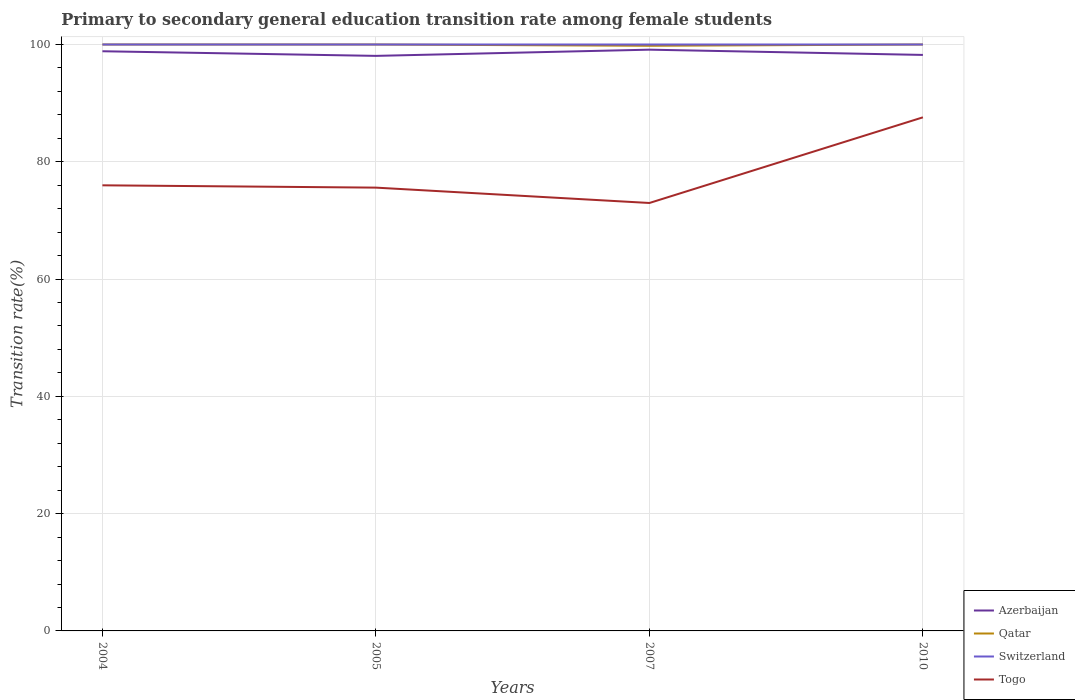How many different coloured lines are there?
Provide a short and direct response. 4. Across all years, what is the maximum transition rate in Azerbaijan?
Make the answer very short. 98.06. What is the total transition rate in Qatar in the graph?
Keep it short and to the point. -0.22. What is the difference between the highest and the second highest transition rate in Togo?
Keep it short and to the point. 14.61. How many years are there in the graph?
Keep it short and to the point. 4. What is the difference between two consecutive major ticks on the Y-axis?
Ensure brevity in your answer.  20. Are the values on the major ticks of Y-axis written in scientific E-notation?
Your response must be concise. No. Does the graph contain any zero values?
Your answer should be compact. No. How many legend labels are there?
Your answer should be compact. 4. What is the title of the graph?
Provide a short and direct response. Primary to secondary general education transition rate among female students. What is the label or title of the X-axis?
Your response must be concise. Years. What is the label or title of the Y-axis?
Your answer should be compact. Transition rate(%). What is the Transition rate(%) in Azerbaijan in 2004?
Offer a very short reply. 98.85. What is the Transition rate(%) in Qatar in 2004?
Offer a very short reply. 100. What is the Transition rate(%) in Togo in 2004?
Provide a short and direct response. 75.99. What is the Transition rate(%) of Azerbaijan in 2005?
Your response must be concise. 98.06. What is the Transition rate(%) in Togo in 2005?
Your response must be concise. 75.59. What is the Transition rate(%) in Azerbaijan in 2007?
Keep it short and to the point. 99.12. What is the Transition rate(%) in Qatar in 2007?
Your response must be concise. 99.78. What is the Transition rate(%) of Switzerland in 2007?
Your answer should be very brief. 100. What is the Transition rate(%) in Togo in 2007?
Ensure brevity in your answer.  72.97. What is the Transition rate(%) in Azerbaijan in 2010?
Provide a short and direct response. 98.22. What is the Transition rate(%) of Qatar in 2010?
Offer a very short reply. 100. What is the Transition rate(%) in Togo in 2010?
Provide a succinct answer. 87.58. Across all years, what is the maximum Transition rate(%) in Azerbaijan?
Your response must be concise. 99.12. Across all years, what is the maximum Transition rate(%) of Qatar?
Offer a terse response. 100. Across all years, what is the maximum Transition rate(%) in Togo?
Make the answer very short. 87.58. Across all years, what is the minimum Transition rate(%) in Azerbaijan?
Provide a succinct answer. 98.06. Across all years, what is the minimum Transition rate(%) of Qatar?
Your response must be concise. 99.78. Across all years, what is the minimum Transition rate(%) in Togo?
Your answer should be compact. 72.97. What is the total Transition rate(%) in Azerbaijan in the graph?
Your response must be concise. 394.25. What is the total Transition rate(%) of Qatar in the graph?
Give a very brief answer. 399.78. What is the total Transition rate(%) of Togo in the graph?
Make the answer very short. 312.14. What is the difference between the Transition rate(%) of Azerbaijan in 2004 and that in 2005?
Ensure brevity in your answer.  0.79. What is the difference between the Transition rate(%) of Togo in 2004 and that in 2005?
Your answer should be very brief. 0.39. What is the difference between the Transition rate(%) of Azerbaijan in 2004 and that in 2007?
Offer a terse response. -0.27. What is the difference between the Transition rate(%) of Qatar in 2004 and that in 2007?
Your response must be concise. 0.22. What is the difference between the Transition rate(%) in Switzerland in 2004 and that in 2007?
Your answer should be compact. 0. What is the difference between the Transition rate(%) in Togo in 2004 and that in 2007?
Give a very brief answer. 3.01. What is the difference between the Transition rate(%) in Azerbaijan in 2004 and that in 2010?
Keep it short and to the point. 0.63. What is the difference between the Transition rate(%) of Switzerland in 2004 and that in 2010?
Make the answer very short. 0. What is the difference between the Transition rate(%) of Togo in 2004 and that in 2010?
Your answer should be compact. -11.59. What is the difference between the Transition rate(%) of Azerbaijan in 2005 and that in 2007?
Provide a short and direct response. -1.06. What is the difference between the Transition rate(%) in Qatar in 2005 and that in 2007?
Provide a short and direct response. 0.22. What is the difference between the Transition rate(%) of Switzerland in 2005 and that in 2007?
Provide a succinct answer. 0. What is the difference between the Transition rate(%) of Togo in 2005 and that in 2007?
Offer a terse response. 2.62. What is the difference between the Transition rate(%) in Azerbaijan in 2005 and that in 2010?
Your answer should be very brief. -0.16. What is the difference between the Transition rate(%) in Qatar in 2005 and that in 2010?
Offer a very short reply. 0. What is the difference between the Transition rate(%) in Switzerland in 2005 and that in 2010?
Provide a succinct answer. 0. What is the difference between the Transition rate(%) of Togo in 2005 and that in 2010?
Your response must be concise. -11.99. What is the difference between the Transition rate(%) of Azerbaijan in 2007 and that in 2010?
Give a very brief answer. 0.9. What is the difference between the Transition rate(%) of Qatar in 2007 and that in 2010?
Your response must be concise. -0.22. What is the difference between the Transition rate(%) of Switzerland in 2007 and that in 2010?
Ensure brevity in your answer.  0. What is the difference between the Transition rate(%) of Togo in 2007 and that in 2010?
Provide a succinct answer. -14.61. What is the difference between the Transition rate(%) in Azerbaijan in 2004 and the Transition rate(%) in Qatar in 2005?
Offer a very short reply. -1.15. What is the difference between the Transition rate(%) of Azerbaijan in 2004 and the Transition rate(%) of Switzerland in 2005?
Keep it short and to the point. -1.15. What is the difference between the Transition rate(%) in Azerbaijan in 2004 and the Transition rate(%) in Togo in 2005?
Your answer should be very brief. 23.25. What is the difference between the Transition rate(%) of Qatar in 2004 and the Transition rate(%) of Switzerland in 2005?
Your response must be concise. 0. What is the difference between the Transition rate(%) of Qatar in 2004 and the Transition rate(%) of Togo in 2005?
Your answer should be compact. 24.41. What is the difference between the Transition rate(%) in Switzerland in 2004 and the Transition rate(%) in Togo in 2005?
Give a very brief answer. 24.41. What is the difference between the Transition rate(%) of Azerbaijan in 2004 and the Transition rate(%) of Qatar in 2007?
Your answer should be very brief. -0.93. What is the difference between the Transition rate(%) in Azerbaijan in 2004 and the Transition rate(%) in Switzerland in 2007?
Give a very brief answer. -1.15. What is the difference between the Transition rate(%) of Azerbaijan in 2004 and the Transition rate(%) of Togo in 2007?
Provide a short and direct response. 25.87. What is the difference between the Transition rate(%) in Qatar in 2004 and the Transition rate(%) in Switzerland in 2007?
Give a very brief answer. 0. What is the difference between the Transition rate(%) in Qatar in 2004 and the Transition rate(%) in Togo in 2007?
Your answer should be very brief. 27.03. What is the difference between the Transition rate(%) in Switzerland in 2004 and the Transition rate(%) in Togo in 2007?
Offer a terse response. 27.03. What is the difference between the Transition rate(%) of Azerbaijan in 2004 and the Transition rate(%) of Qatar in 2010?
Offer a very short reply. -1.15. What is the difference between the Transition rate(%) in Azerbaijan in 2004 and the Transition rate(%) in Switzerland in 2010?
Provide a succinct answer. -1.15. What is the difference between the Transition rate(%) in Azerbaijan in 2004 and the Transition rate(%) in Togo in 2010?
Offer a terse response. 11.27. What is the difference between the Transition rate(%) in Qatar in 2004 and the Transition rate(%) in Togo in 2010?
Ensure brevity in your answer.  12.42. What is the difference between the Transition rate(%) of Switzerland in 2004 and the Transition rate(%) of Togo in 2010?
Make the answer very short. 12.42. What is the difference between the Transition rate(%) of Azerbaijan in 2005 and the Transition rate(%) of Qatar in 2007?
Your answer should be compact. -1.72. What is the difference between the Transition rate(%) of Azerbaijan in 2005 and the Transition rate(%) of Switzerland in 2007?
Provide a succinct answer. -1.94. What is the difference between the Transition rate(%) in Azerbaijan in 2005 and the Transition rate(%) in Togo in 2007?
Give a very brief answer. 25.09. What is the difference between the Transition rate(%) of Qatar in 2005 and the Transition rate(%) of Togo in 2007?
Provide a short and direct response. 27.03. What is the difference between the Transition rate(%) of Switzerland in 2005 and the Transition rate(%) of Togo in 2007?
Offer a terse response. 27.03. What is the difference between the Transition rate(%) in Azerbaijan in 2005 and the Transition rate(%) in Qatar in 2010?
Ensure brevity in your answer.  -1.94. What is the difference between the Transition rate(%) of Azerbaijan in 2005 and the Transition rate(%) of Switzerland in 2010?
Ensure brevity in your answer.  -1.94. What is the difference between the Transition rate(%) in Azerbaijan in 2005 and the Transition rate(%) in Togo in 2010?
Your response must be concise. 10.48. What is the difference between the Transition rate(%) in Qatar in 2005 and the Transition rate(%) in Switzerland in 2010?
Your answer should be very brief. 0. What is the difference between the Transition rate(%) of Qatar in 2005 and the Transition rate(%) of Togo in 2010?
Offer a very short reply. 12.42. What is the difference between the Transition rate(%) of Switzerland in 2005 and the Transition rate(%) of Togo in 2010?
Provide a short and direct response. 12.42. What is the difference between the Transition rate(%) in Azerbaijan in 2007 and the Transition rate(%) in Qatar in 2010?
Your answer should be compact. -0.88. What is the difference between the Transition rate(%) in Azerbaijan in 2007 and the Transition rate(%) in Switzerland in 2010?
Offer a very short reply. -0.88. What is the difference between the Transition rate(%) in Azerbaijan in 2007 and the Transition rate(%) in Togo in 2010?
Ensure brevity in your answer.  11.54. What is the difference between the Transition rate(%) of Qatar in 2007 and the Transition rate(%) of Switzerland in 2010?
Make the answer very short. -0.22. What is the difference between the Transition rate(%) in Qatar in 2007 and the Transition rate(%) in Togo in 2010?
Your answer should be compact. 12.2. What is the difference between the Transition rate(%) in Switzerland in 2007 and the Transition rate(%) in Togo in 2010?
Offer a terse response. 12.42. What is the average Transition rate(%) in Azerbaijan per year?
Ensure brevity in your answer.  98.56. What is the average Transition rate(%) of Qatar per year?
Offer a very short reply. 99.95. What is the average Transition rate(%) of Switzerland per year?
Provide a succinct answer. 100. What is the average Transition rate(%) in Togo per year?
Ensure brevity in your answer.  78.03. In the year 2004, what is the difference between the Transition rate(%) in Azerbaijan and Transition rate(%) in Qatar?
Make the answer very short. -1.15. In the year 2004, what is the difference between the Transition rate(%) in Azerbaijan and Transition rate(%) in Switzerland?
Make the answer very short. -1.15. In the year 2004, what is the difference between the Transition rate(%) in Azerbaijan and Transition rate(%) in Togo?
Provide a succinct answer. 22.86. In the year 2004, what is the difference between the Transition rate(%) of Qatar and Transition rate(%) of Switzerland?
Make the answer very short. 0. In the year 2004, what is the difference between the Transition rate(%) of Qatar and Transition rate(%) of Togo?
Make the answer very short. 24.01. In the year 2004, what is the difference between the Transition rate(%) of Switzerland and Transition rate(%) of Togo?
Your answer should be compact. 24.01. In the year 2005, what is the difference between the Transition rate(%) in Azerbaijan and Transition rate(%) in Qatar?
Your answer should be compact. -1.94. In the year 2005, what is the difference between the Transition rate(%) in Azerbaijan and Transition rate(%) in Switzerland?
Your response must be concise. -1.94. In the year 2005, what is the difference between the Transition rate(%) of Azerbaijan and Transition rate(%) of Togo?
Your response must be concise. 22.47. In the year 2005, what is the difference between the Transition rate(%) of Qatar and Transition rate(%) of Switzerland?
Offer a terse response. 0. In the year 2005, what is the difference between the Transition rate(%) of Qatar and Transition rate(%) of Togo?
Offer a terse response. 24.41. In the year 2005, what is the difference between the Transition rate(%) in Switzerland and Transition rate(%) in Togo?
Your response must be concise. 24.41. In the year 2007, what is the difference between the Transition rate(%) of Azerbaijan and Transition rate(%) of Qatar?
Your response must be concise. -0.66. In the year 2007, what is the difference between the Transition rate(%) in Azerbaijan and Transition rate(%) in Switzerland?
Offer a very short reply. -0.88. In the year 2007, what is the difference between the Transition rate(%) in Azerbaijan and Transition rate(%) in Togo?
Give a very brief answer. 26.14. In the year 2007, what is the difference between the Transition rate(%) of Qatar and Transition rate(%) of Switzerland?
Offer a terse response. -0.22. In the year 2007, what is the difference between the Transition rate(%) of Qatar and Transition rate(%) of Togo?
Keep it short and to the point. 26.81. In the year 2007, what is the difference between the Transition rate(%) of Switzerland and Transition rate(%) of Togo?
Make the answer very short. 27.03. In the year 2010, what is the difference between the Transition rate(%) in Azerbaijan and Transition rate(%) in Qatar?
Your response must be concise. -1.78. In the year 2010, what is the difference between the Transition rate(%) of Azerbaijan and Transition rate(%) of Switzerland?
Keep it short and to the point. -1.78. In the year 2010, what is the difference between the Transition rate(%) of Azerbaijan and Transition rate(%) of Togo?
Ensure brevity in your answer.  10.64. In the year 2010, what is the difference between the Transition rate(%) in Qatar and Transition rate(%) in Togo?
Keep it short and to the point. 12.42. In the year 2010, what is the difference between the Transition rate(%) of Switzerland and Transition rate(%) of Togo?
Your answer should be compact. 12.42. What is the ratio of the Transition rate(%) in Azerbaijan in 2004 to that in 2005?
Provide a succinct answer. 1.01. What is the ratio of the Transition rate(%) of Qatar in 2004 to that in 2005?
Provide a succinct answer. 1. What is the ratio of the Transition rate(%) of Switzerland in 2004 to that in 2005?
Give a very brief answer. 1. What is the ratio of the Transition rate(%) of Togo in 2004 to that in 2005?
Give a very brief answer. 1.01. What is the ratio of the Transition rate(%) in Azerbaijan in 2004 to that in 2007?
Provide a succinct answer. 1. What is the ratio of the Transition rate(%) in Togo in 2004 to that in 2007?
Provide a succinct answer. 1.04. What is the ratio of the Transition rate(%) in Azerbaijan in 2004 to that in 2010?
Offer a very short reply. 1.01. What is the ratio of the Transition rate(%) of Togo in 2004 to that in 2010?
Make the answer very short. 0.87. What is the ratio of the Transition rate(%) in Azerbaijan in 2005 to that in 2007?
Offer a very short reply. 0.99. What is the ratio of the Transition rate(%) in Qatar in 2005 to that in 2007?
Give a very brief answer. 1. What is the ratio of the Transition rate(%) of Switzerland in 2005 to that in 2007?
Give a very brief answer. 1. What is the ratio of the Transition rate(%) of Togo in 2005 to that in 2007?
Give a very brief answer. 1.04. What is the ratio of the Transition rate(%) in Azerbaijan in 2005 to that in 2010?
Offer a very short reply. 1. What is the ratio of the Transition rate(%) of Qatar in 2005 to that in 2010?
Ensure brevity in your answer.  1. What is the ratio of the Transition rate(%) in Switzerland in 2005 to that in 2010?
Keep it short and to the point. 1. What is the ratio of the Transition rate(%) of Togo in 2005 to that in 2010?
Your response must be concise. 0.86. What is the ratio of the Transition rate(%) in Azerbaijan in 2007 to that in 2010?
Provide a short and direct response. 1.01. What is the ratio of the Transition rate(%) in Switzerland in 2007 to that in 2010?
Offer a terse response. 1. What is the ratio of the Transition rate(%) in Togo in 2007 to that in 2010?
Offer a very short reply. 0.83. What is the difference between the highest and the second highest Transition rate(%) of Azerbaijan?
Make the answer very short. 0.27. What is the difference between the highest and the second highest Transition rate(%) of Switzerland?
Ensure brevity in your answer.  0. What is the difference between the highest and the second highest Transition rate(%) in Togo?
Provide a succinct answer. 11.59. What is the difference between the highest and the lowest Transition rate(%) in Azerbaijan?
Your answer should be compact. 1.06. What is the difference between the highest and the lowest Transition rate(%) of Qatar?
Ensure brevity in your answer.  0.22. What is the difference between the highest and the lowest Transition rate(%) of Togo?
Your answer should be very brief. 14.61. 